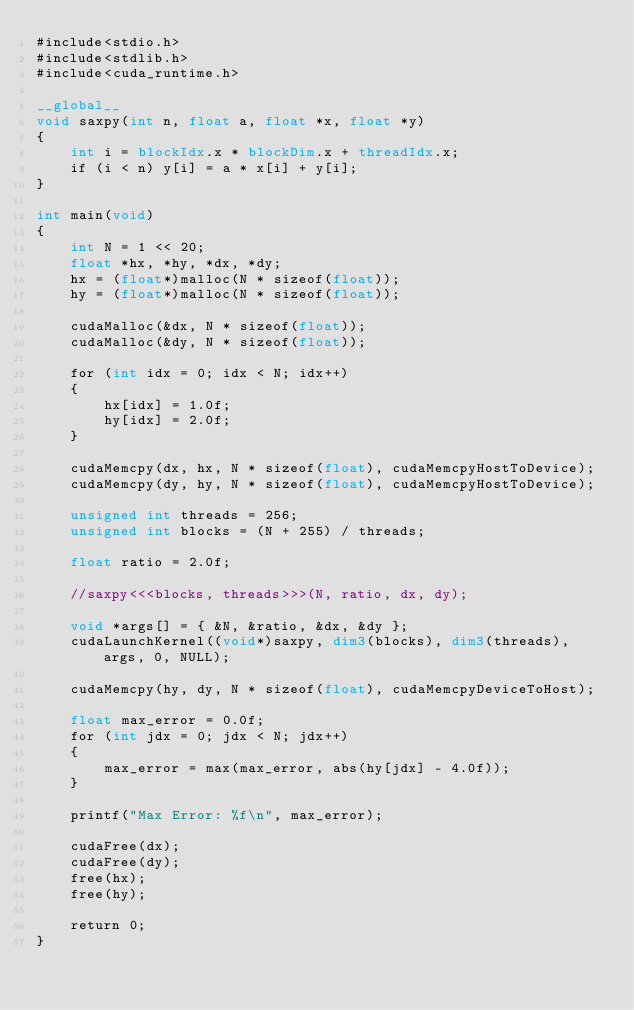Convert code to text. <code><loc_0><loc_0><loc_500><loc_500><_Cuda_>#include<stdio.h>
#include<stdlib.h>
#include<cuda_runtime.h>

__global__
void saxpy(int n, float a, float *x, float *y)
{
    int i = blockIdx.x * blockDim.x + threadIdx.x;
    if (i < n) y[i] = a * x[i] + y[i];
}

int main(void)
{
    int N = 1 << 20;
    float *hx, *hy, *dx, *dy;
    hx = (float*)malloc(N * sizeof(float));
    hy = (float*)malloc(N * sizeof(float));

    cudaMalloc(&dx, N * sizeof(float));
    cudaMalloc(&dy, N * sizeof(float));

    for (int idx = 0; idx < N; idx++)
    {
        hx[idx] = 1.0f;
        hy[idx] = 2.0f;
    }

    cudaMemcpy(dx, hx, N * sizeof(float), cudaMemcpyHostToDevice);
    cudaMemcpy(dy, hy, N * sizeof(float), cudaMemcpyHostToDevice);

    unsigned int threads = 256;
    unsigned int blocks = (N + 255) / threads;

    float ratio = 2.0f;

    //saxpy<<<blocks, threads>>>(N, ratio, dx, dy);

    void *args[] = { &N, &ratio, &dx, &dy };
    cudaLaunchKernel((void*)saxpy, dim3(blocks), dim3(threads), args, 0, NULL);

    cudaMemcpy(hy, dy, N * sizeof(float), cudaMemcpyDeviceToHost);

    float max_error = 0.0f;
    for (int jdx = 0; jdx < N; jdx++)
    {
        max_error = max(max_error, abs(hy[jdx] - 4.0f));
    }

    printf("Max Error: %f\n", max_error);

    cudaFree(dx);
    cudaFree(dy);
    free(hx);
    free(hy);

    return 0;
}
</code> 